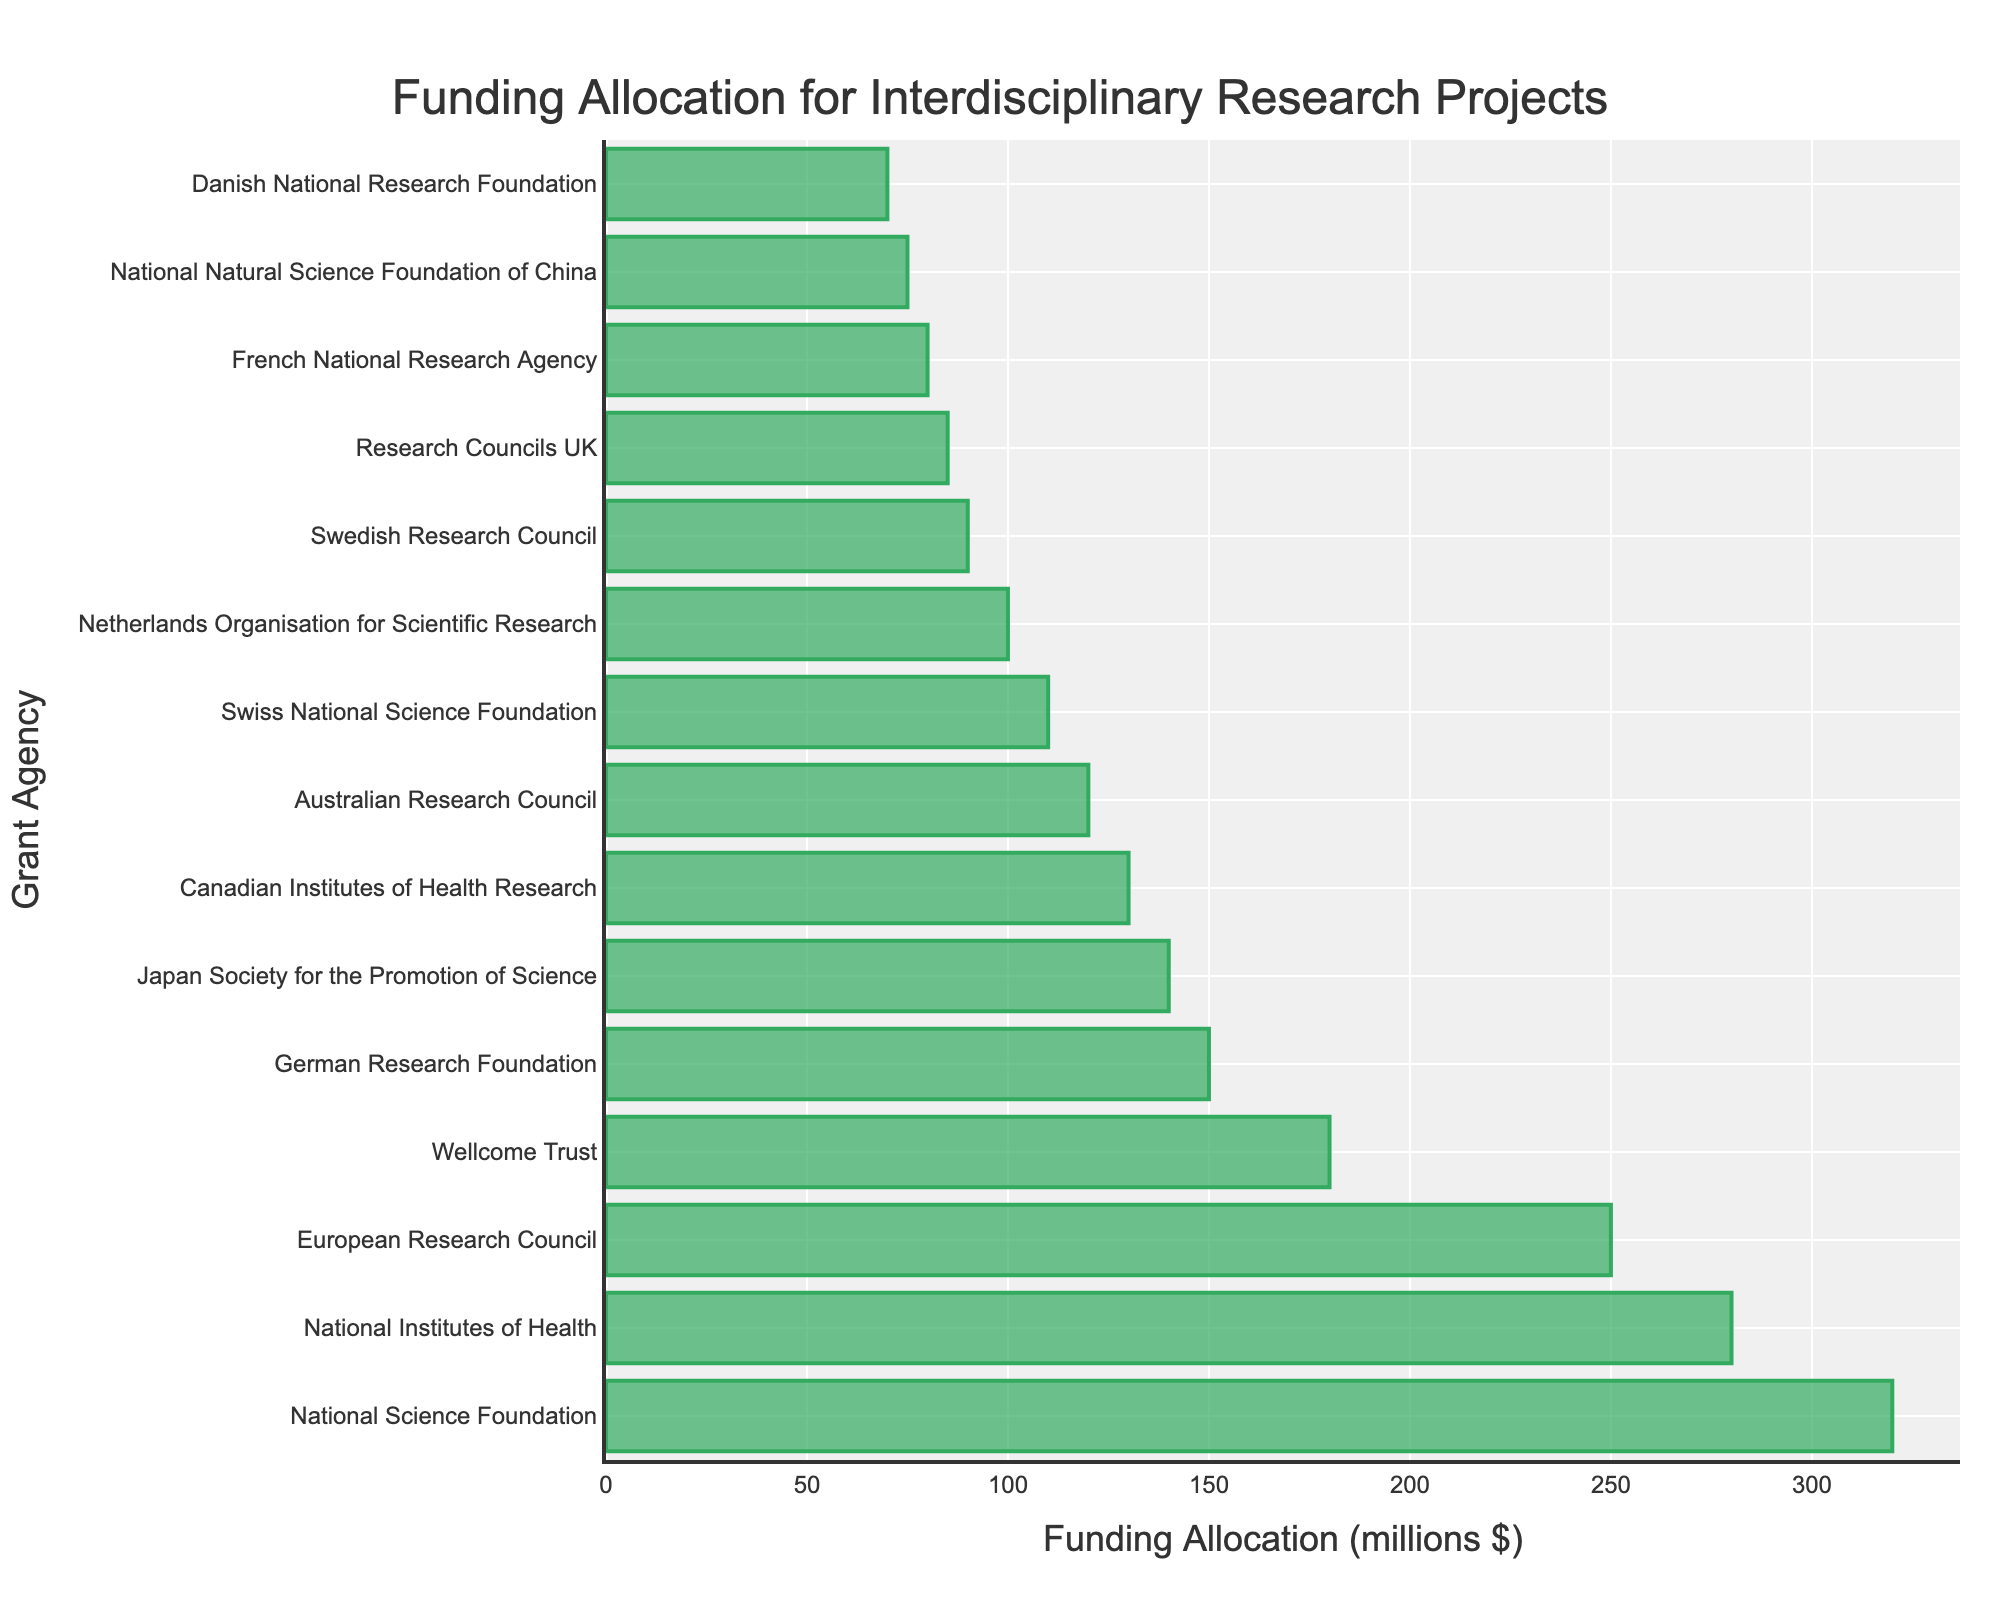What is the total funding allocation by the top three grant agencies? The top three grant agencies in the bar chart are the National Science Foundation, National Institutes of Health, and European Research Council. Sum their funding allocations: 320 + 280 + 250 = 850 million dollars.
Answer: 850 million $ Which grant agency has the lowest funding allocation and how much is it? The grant agency with the lowest funding allocation is the Danish National Research Foundation, with 70 million dollars.
Answer: Danish National Research Foundation, 70 million $ What is the difference in funding allocation between the National Science Foundation and the Wellcome Trust? Subtract the funding allocation for the Wellcome Trust (180 million dollars) from the National Science Foundation's allocation (320 million dollars): 320 - 180 = 140 million dollars.
Answer: 140 million $ Which grant agencies have funding allocations greater than 200 million dollars? The grant agencies with funding allocations greater than 200 million dollars are the National Science Foundation (320 million $), National Institutes of Health (280 million $), and European Research Council (250 million $).
Answer: National Science Foundation, National Institutes of Health, European Research Council What is the average funding allocation of grant agencies with allocations less than 100 million dollars? First, identify relevant grant agencies: Swedish Research Council (90 million $), Research Councils UK (85 million $), French National Research Agency (80 million $), National Natural Science Foundation of China (75 million $), Danish National Research Foundation (70 million $). Sum their allocations: 90 + 85 + 80 + 75 + 70 = 400 million dollars. Divide by the number of agencies: 400 / 5 = 80 million dollars.
Answer: 80 million $ Which grant agency is in the middle in terms of funding allocation and what is the value? Sort the grant agencies by funding allocation. The median agency in a sorted list of 15 is the 8th one: Australian Research Council with 120 million dollars.
Answer: Australian Research Council, 120 million $ How many grant agencies have funding allocations between 100 million dollars and 200 million dollars? Identify the grant agencies with funding allocations within this range: German Research Foundation (150 million $), Japan Society for the Promotion of Science (140 million $), Canadian Institutes of Health Research (130 million $), Australian Research Council (120 million $), Swiss National Science Foundation (110 million $), and Netherlands Organisation for Scientific Research (100 million $). There are 6 agencies in this range.
Answer: 6 agencies What is the combined funding allocation of the European and Canadian grant agencies listed? Sum the funding allocations for European Research Council (250 million $), German Research Foundation (150 million $), Swiss National Science Foundation (110 million $), Netherlands Organisation for Scientific Research (100 million $), and Swedish Research Council (90 million $) plus Canadian Institutes of Health Research (130 million $): 250 + 150 + 110 + 100 + 90 + 130 = 830 million dollars.
Answer: 830 million $ Which grant agency's bar appears tallest and which appears shortest? The tallest bar represents the National Science Foundation, and the shortest bar represents the Danish National Research Foundation.
Answer: National Science Foundation, Danish National Research Foundation 